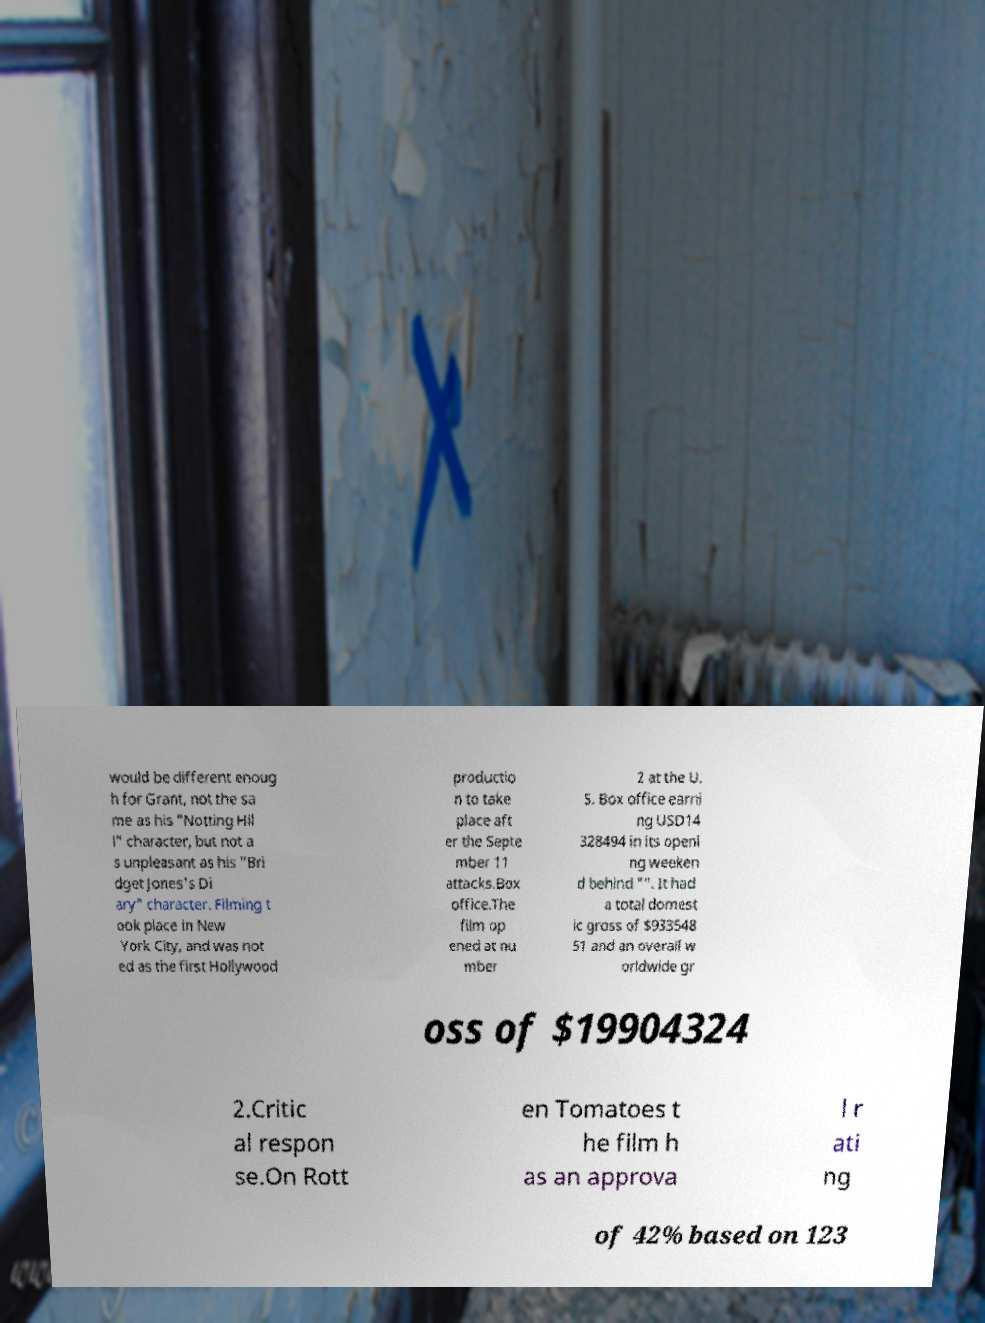Can you read and provide the text displayed in the image?This photo seems to have some interesting text. Can you extract and type it out for me? would be different enoug h for Grant, not the sa me as his "Notting Hil l" character, but not a s unpleasant as his "Bri dget Jones's Di ary" character. Filming t ook place in New York City, and was not ed as the first Hollywood productio n to take place aft er the Septe mber 11 attacks.Box office.The film op ened at nu mber 2 at the U. S. Box office earni ng USD14 328494 in its openi ng weeken d behind "". It had a total domest ic gross of $933548 51 and an overall w orldwide gr oss of $19904324 2.Critic al respon se.On Rott en Tomatoes t he film h as an approva l r ati ng of 42% based on 123 